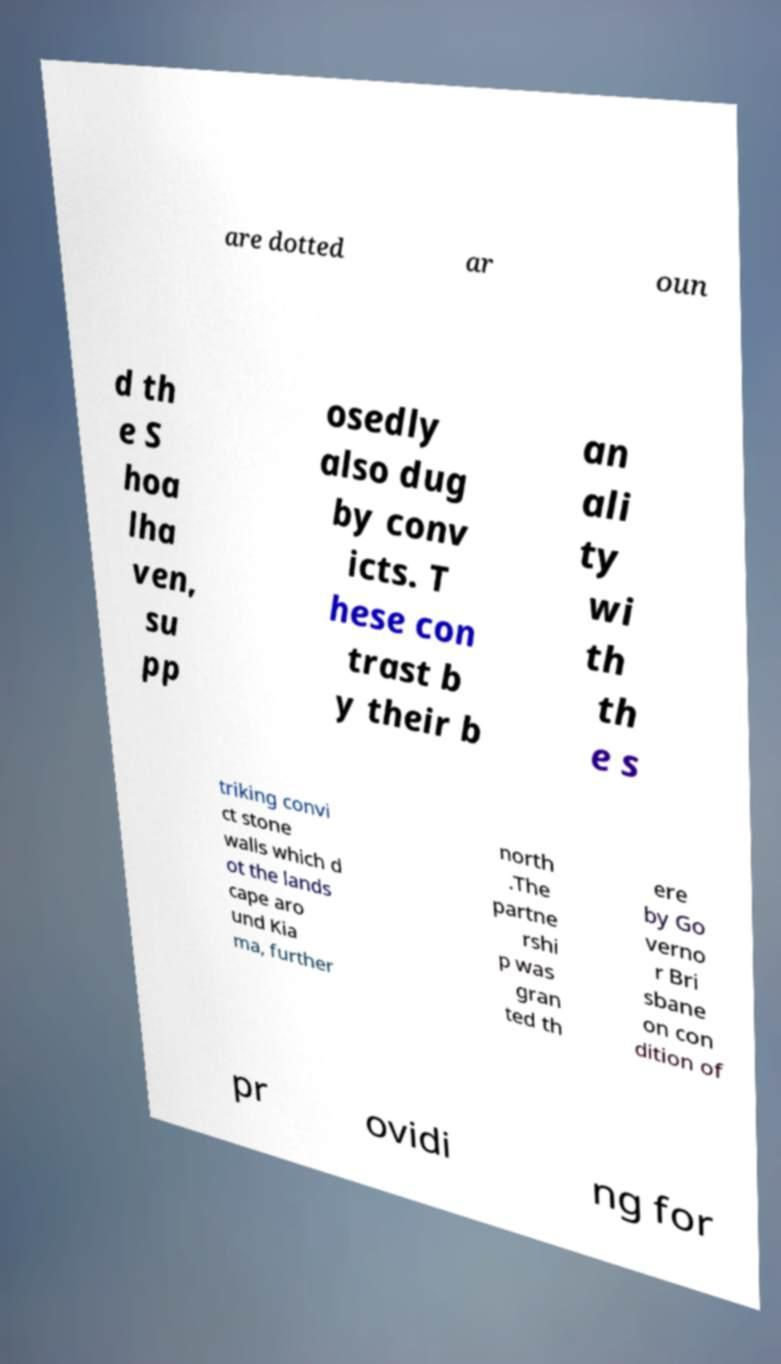Can you read and provide the text displayed in the image?This photo seems to have some interesting text. Can you extract and type it out for me? are dotted ar oun d th e S hoa lha ven, su pp osedly also dug by conv icts. T hese con trast b y their b an ali ty wi th th e s triking convi ct stone walls which d ot the lands cape aro und Kia ma, further north .The partne rshi p was gran ted th ere by Go verno r Bri sbane on con dition of pr ovidi ng for 